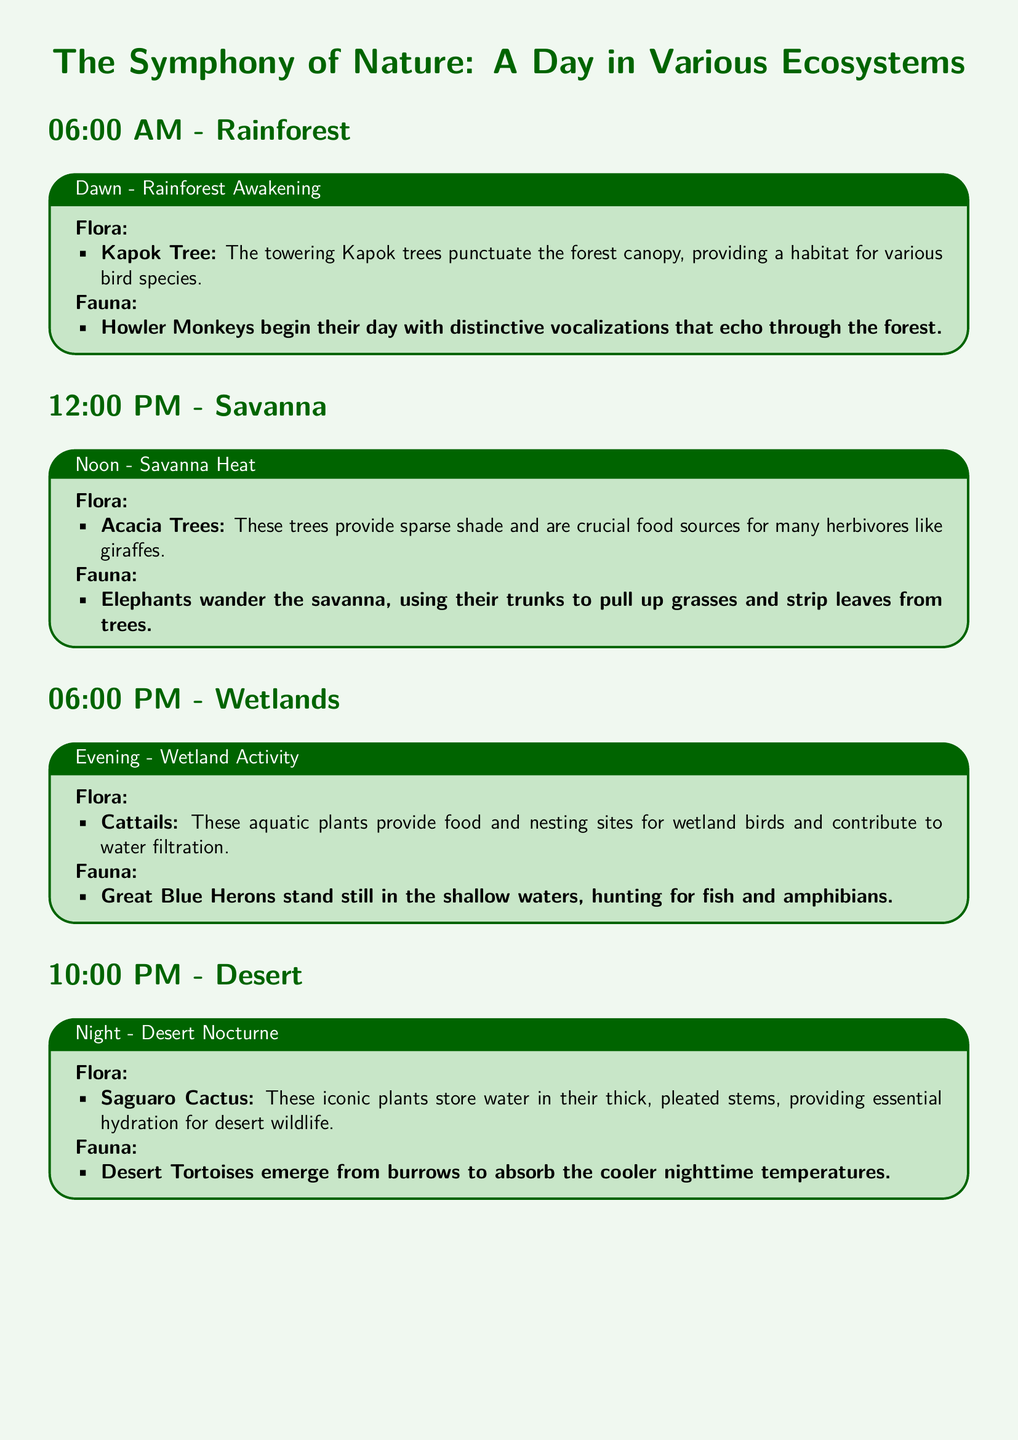What time does the rainforest section start? The transcript states that the rainforest section begins at 06:00 AM.
Answer: 06:00 AM What tree is notable in the rainforest ecosystem? The document highlights the Kapok Tree as a significant species in the rainforest.
Answer: Kapok Tree Which animal vocalizes at dawn in the rainforest? According to the document, Howler Monkeys are mentioned as vocalizing at dawn.
Answer: Howler Monkeys What type of tree is found in the savanna? The transcript identifies Acacia Trees as prevalent in the savanna environment.
Answer: Acacia Trees What activity do Great Blue Herons engage in at wetlands? The document states that Great Blue Herons hunt for fish and amphibians in the wetlands.
Answer: Hunting What adaptation helps Saguaro Cactus survive in the desert? The document notes that Saguaro Cactus stores water in its thick, pleated stems.
Answer: Stores water What is one environmental interaction in the savanna? The text mentions that periodic fires help in nutrient recycling within the savanna.
Answer: Periodic fires How many ecosystems are described in the document? The document describes a total of four ecosystems.
Answer: Four 